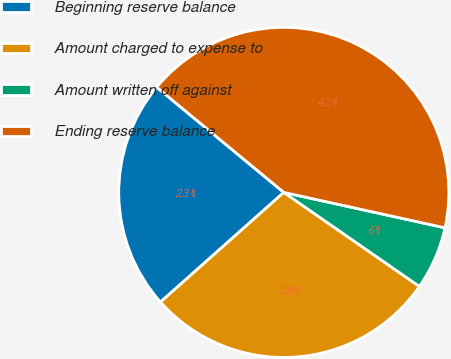Convert chart. <chart><loc_0><loc_0><loc_500><loc_500><pie_chart><fcel>Beginning reserve balance<fcel>Amount charged to expense to<fcel>Amount written off against<fcel>Ending reserve balance<nl><fcel>22.57%<fcel>28.78%<fcel>6.21%<fcel>42.44%<nl></chart> 